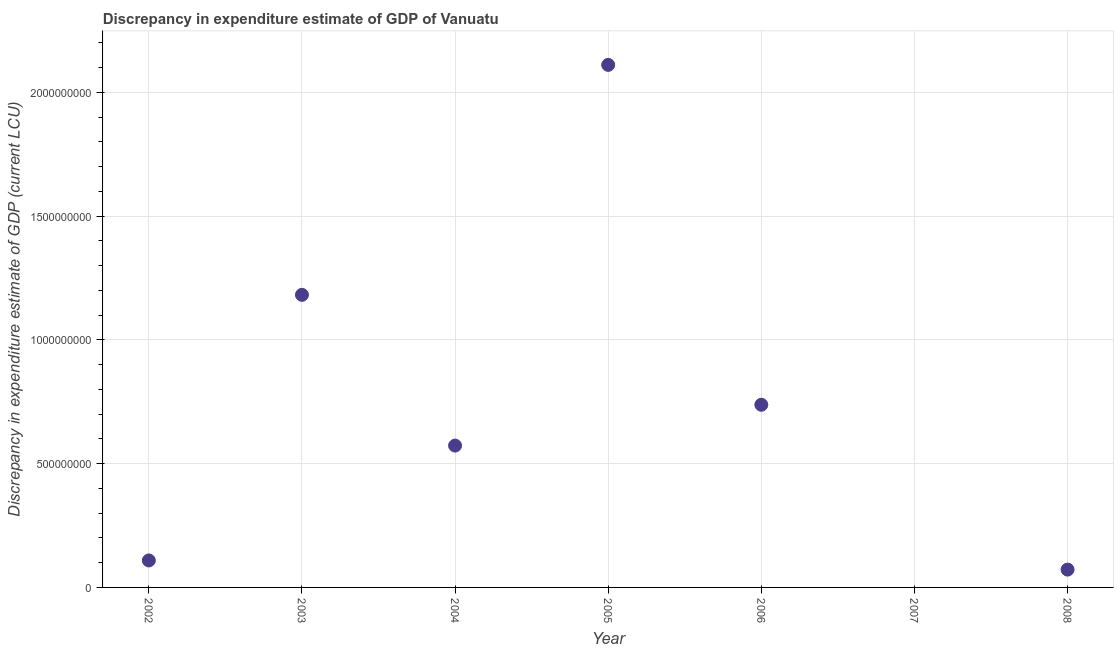What is the discrepancy in expenditure estimate of gdp in 2002?
Provide a short and direct response. 1.09e+08. Across all years, what is the maximum discrepancy in expenditure estimate of gdp?
Your answer should be compact. 2.11e+09. Across all years, what is the minimum discrepancy in expenditure estimate of gdp?
Give a very brief answer. 0. In which year was the discrepancy in expenditure estimate of gdp maximum?
Provide a succinct answer. 2005. What is the sum of the discrepancy in expenditure estimate of gdp?
Make the answer very short. 4.78e+09. What is the difference between the discrepancy in expenditure estimate of gdp in 2006 and 2008?
Your answer should be compact. 6.66e+08. What is the average discrepancy in expenditure estimate of gdp per year?
Ensure brevity in your answer.  6.84e+08. What is the median discrepancy in expenditure estimate of gdp?
Offer a terse response. 5.73e+08. What is the ratio of the discrepancy in expenditure estimate of gdp in 2002 to that in 2006?
Make the answer very short. 0.15. Is the discrepancy in expenditure estimate of gdp in 2003 less than that in 2005?
Offer a very short reply. Yes. What is the difference between the highest and the second highest discrepancy in expenditure estimate of gdp?
Offer a terse response. 9.29e+08. What is the difference between the highest and the lowest discrepancy in expenditure estimate of gdp?
Keep it short and to the point. 2.11e+09. In how many years, is the discrepancy in expenditure estimate of gdp greater than the average discrepancy in expenditure estimate of gdp taken over all years?
Offer a terse response. 3. How many years are there in the graph?
Keep it short and to the point. 7. Are the values on the major ticks of Y-axis written in scientific E-notation?
Offer a terse response. No. Does the graph contain grids?
Provide a short and direct response. Yes. What is the title of the graph?
Your answer should be compact. Discrepancy in expenditure estimate of GDP of Vanuatu. What is the label or title of the X-axis?
Offer a terse response. Year. What is the label or title of the Y-axis?
Make the answer very short. Discrepancy in expenditure estimate of GDP (current LCU). What is the Discrepancy in expenditure estimate of GDP (current LCU) in 2002?
Offer a terse response. 1.09e+08. What is the Discrepancy in expenditure estimate of GDP (current LCU) in 2003?
Provide a succinct answer. 1.18e+09. What is the Discrepancy in expenditure estimate of GDP (current LCU) in 2004?
Offer a terse response. 5.73e+08. What is the Discrepancy in expenditure estimate of GDP (current LCU) in 2005?
Offer a very short reply. 2.11e+09. What is the Discrepancy in expenditure estimate of GDP (current LCU) in 2006?
Provide a short and direct response. 7.38e+08. What is the Discrepancy in expenditure estimate of GDP (current LCU) in 2007?
Your answer should be compact. 0. What is the Discrepancy in expenditure estimate of GDP (current LCU) in 2008?
Your answer should be compact. 7.20e+07. What is the difference between the Discrepancy in expenditure estimate of GDP (current LCU) in 2002 and 2003?
Offer a very short reply. -1.07e+09. What is the difference between the Discrepancy in expenditure estimate of GDP (current LCU) in 2002 and 2004?
Provide a succinct answer. -4.64e+08. What is the difference between the Discrepancy in expenditure estimate of GDP (current LCU) in 2002 and 2005?
Ensure brevity in your answer.  -2.00e+09. What is the difference between the Discrepancy in expenditure estimate of GDP (current LCU) in 2002 and 2006?
Provide a succinct answer. -6.29e+08. What is the difference between the Discrepancy in expenditure estimate of GDP (current LCU) in 2002 and 2008?
Provide a succinct answer. 3.70e+07. What is the difference between the Discrepancy in expenditure estimate of GDP (current LCU) in 2003 and 2004?
Provide a succinct answer. 6.09e+08. What is the difference between the Discrepancy in expenditure estimate of GDP (current LCU) in 2003 and 2005?
Make the answer very short. -9.29e+08. What is the difference between the Discrepancy in expenditure estimate of GDP (current LCU) in 2003 and 2006?
Provide a succinct answer. 4.44e+08. What is the difference between the Discrepancy in expenditure estimate of GDP (current LCU) in 2003 and 2008?
Your response must be concise. 1.11e+09. What is the difference between the Discrepancy in expenditure estimate of GDP (current LCU) in 2004 and 2005?
Offer a very short reply. -1.54e+09. What is the difference between the Discrepancy in expenditure estimate of GDP (current LCU) in 2004 and 2006?
Offer a very short reply. -1.65e+08. What is the difference between the Discrepancy in expenditure estimate of GDP (current LCU) in 2004 and 2008?
Provide a succinct answer. 5.01e+08. What is the difference between the Discrepancy in expenditure estimate of GDP (current LCU) in 2005 and 2006?
Make the answer very short. 1.37e+09. What is the difference between the Discrepancy in expenditure estimate of GDP (current LCU) in 2005 and 2008?
Provide a short and direct response. 2.04e+09. What is the difference between the Discrepancy in expenditure estimate of GDP (current LCU) in 2006 and 2008?
Provide a short and direct response. 6.66e+08. What is the ratio of the Discrepancy in expenditure estimate of GDP (current LCU) in 2002 to that in 2003?
Make the answer very short. 0.09. What is the ratio of the Discrepancy in expenditure estimate of GDP (current LCU) in 2002 to that in 2004?
Keep it short and to the point. 0.19. What is the ratio of the Discrepancy in expenditure estimate of GDP (current LCU) in 2002 to that in 2005?
Offer a terse response. 0.05. What is the ratio of the Discrepancy in expenditure estimate of GDP (current LCU) in 2002 to that in 2006?
Offer a very short reply. 0.15. What is the ratio of the Discrepancy in expenditure estimate of GDP (current LCU) in 2002 to that in 2008?
Ensure brevity in your answer.  1.51. What is the ratio of the Discrepancy in expenditure estimate of GDP (current LCU) in 2003 to that in 2004?
Provide a succinct answer. 2.06. What is the ratio of the Discrepancy in expenditure estimate of GDP (current LCU) in 2003 to that in 2005?
Your answer should be very brief. 0.56. What is the ratio of the Discrepancy in expenditure estimate of GDP (current LCU) in 2003 to that in 2006?
Provide a short and direct response. 1.6. What is the ratio of the Discrepancy in expenditure estimate of GDP (current LCU) in 2003 to that in 2008?
Offer a terse response. 16.42. What is the ratio of the Discrepancy in expenditure estimate of GDP (current LCU) in 2004 to that in 2005?
Give a very brief answer. 0.27. What is the ratio of the Discrepancy in expenditure estimate of GDP (current LCU) in 2004 to that in 2006?
Keep it short and to the point. 0.78. What is the ratio of the Discrepancy in expenditure estimate of GDP (current LCU) in 2004 to that in 2008?
Provide a succinct answer. 7.96. What is the ratio of the Discrepancy in expenditure estimate of GDP (current LCU) in 2005 to that in 2006?
Your response must be concise. 2.86. What is the ratio of the Discrepancy in expenditure estimate of GDP (current LCU) in 2005 to that in 2008?
Give a very brief answer. 29.32. What is the ratio of the Discrepancy in expenditure estimate of GDP (current LCU) in 2006 to that in 2008?
Offer a terse response. 10.25. 